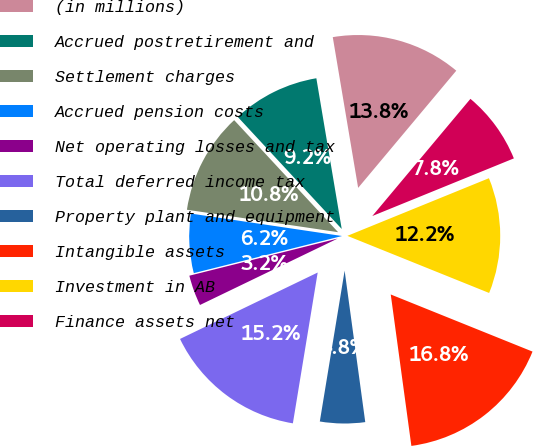Convert chart. <chart><loc_0><loc_0><loc_500><loc_500><pie_chart><fcel>(in millions)<fcel>Accrued postretirement and<fcel>Settlement charges<fcel>Accrued pension costs<fcel>Net operating losses and tax<fcel>Total deferred income tax<fcel>Property plant and equipment<fcel>Intangible assets<fcel>Investment in AB<fcel>Finance assets net<nl><fcel>13.75%<fcel>9.25%<fcel>10.75%<fcel>6.25%<fcel>3.25%<fcel>15.25%<fcel>4.75%<fcel>16.75%<fcel>12.25%<fcel>7.75%<nl></chart> 